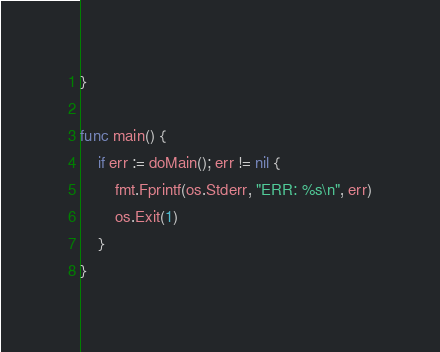<code> <loc_0><loc_0><loc_500><loc_500><_Go_>}

func main() {
	if err := doMain(); err != nil {
		fmt.Fprintf(os.Stderr, "ERR: %s\n", err)
		os.Exit(1)
	}
}
</code> 